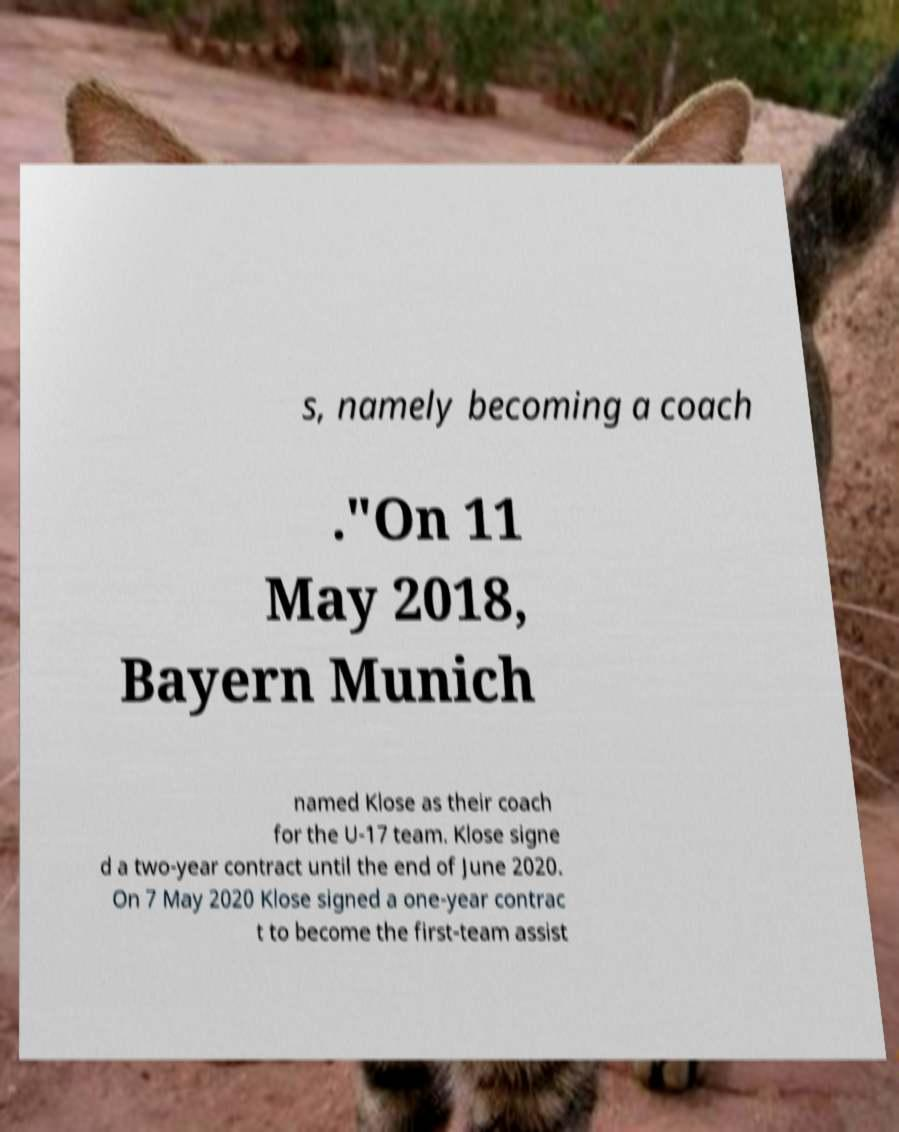Could you extract and type out the text from this image? s, namely becoming a coach ."On 11 May 2018, Bayern Munich named Klose as their coach for the U-17 team. Klose signe d a two-year contract until the end of June 2020. On 7 May 2020 Klose signed a one-year contrac t to become the first-team assist 